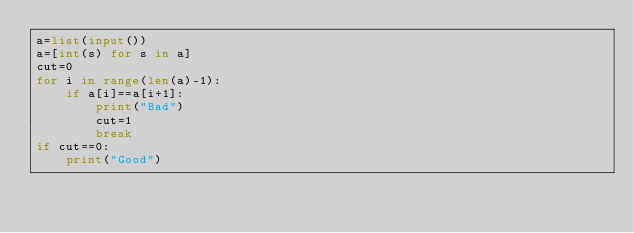<code> <loc_0><loc_0><loc_500><loc_500><_Python_>a=list(input())
a=[int(s) for s in a]
cut=0
for i in range(len(a)-1):
    if a[i]==a[i+1]:
        print("Bad")
        cut=1
        break
if cut==0:
    print("Good")</code> 